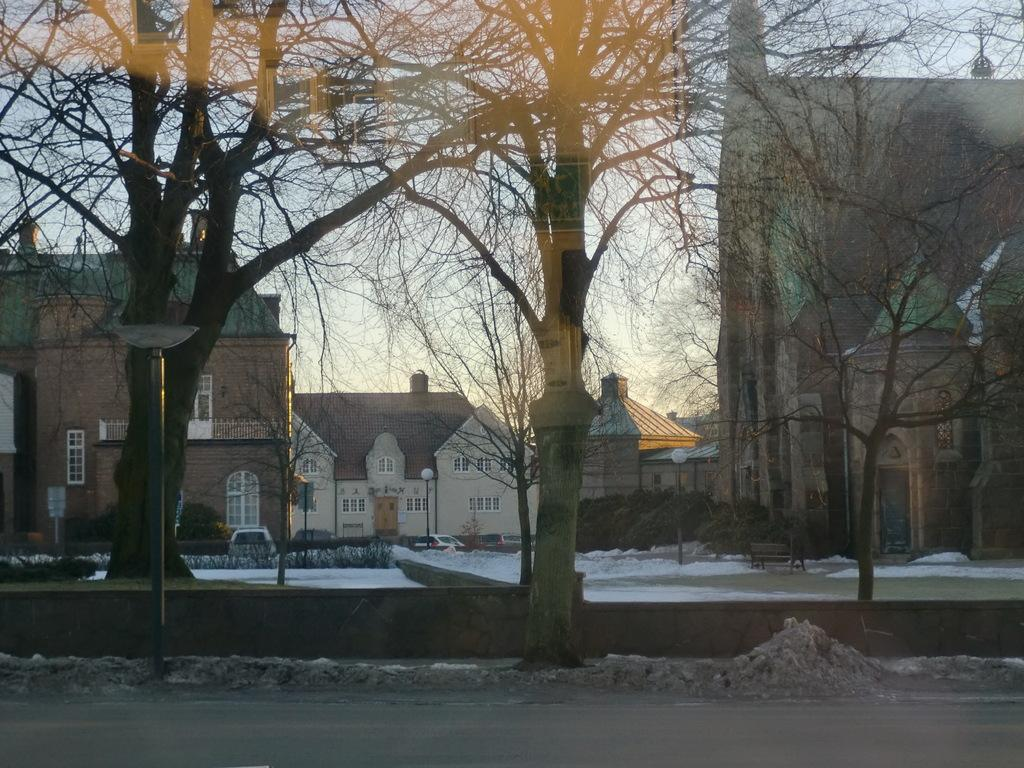What type of structures can be seen in the image? There are buildings in the image. What other natural elements are present in the image? There are trees in the image. Are there any artificial light sources visible in the image? Yes, there are pole lights in the image. What type of seating is available in the image? There is a bench in the image. Is there any transportation visible in the image? Yes, a car is parked in the image. How would you describe the weather in the image? The sky is cloudy, and there is snow on the ground in the image. Can you see a pin holding up the airplane in the image? There is no airplane present in the image, and therefore no pin holding it up. What is the highest point in the image? The image does not have a specific highest point, as it is a scene with multiple elements of varying heights. 